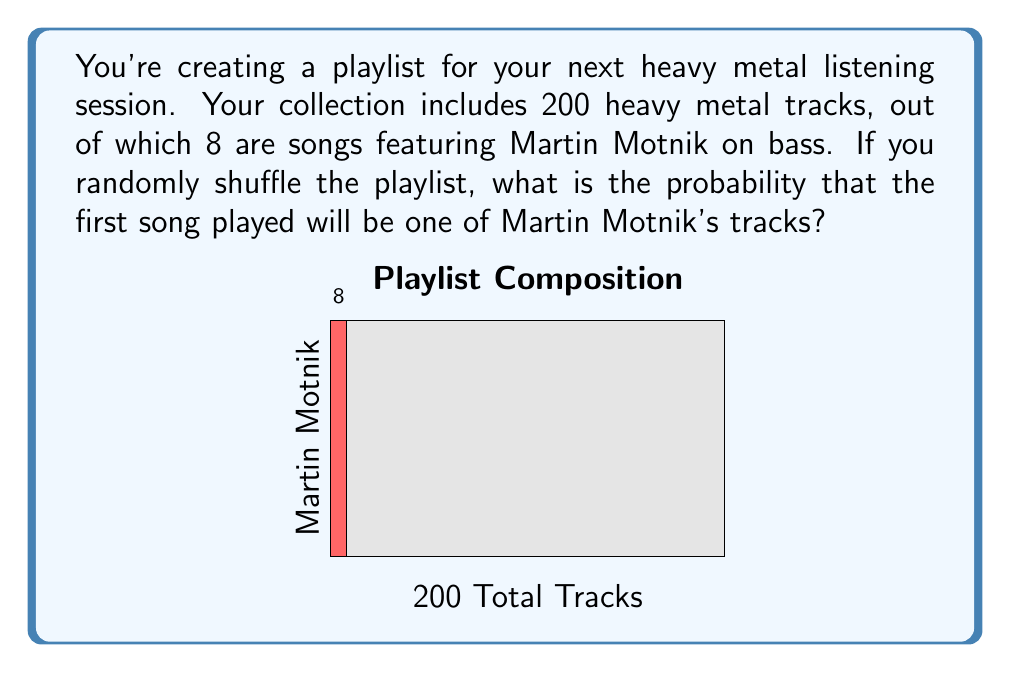Solve this math problem. Let's approach this step-by-step:

1) First, we need to identify the probability space:
   - Total number of tracks: 200
   - Number of tracks featuring Martin Motnik: 8

2) The probability of an event is calculated by:

   $$P(\text{event}) = \frac{\text{number of favorable outcomes}}{\text{total number of possible outcomes}}$$

3) In this case:
   - Favorable outcomes: 8 (Martin Motnik tracks)
   - Total possible outcomes: 200 (all tracks)

4) Applying the formula:

   $$P(\text{Martin Motnik track}) = \frac{8}{200}$$

5) Simplify the fraction:

   $$P(\text{Martin Motnik track}) = \frac{1}{25} = 0.04$$

6) Convert to percentage:

   $$0.04 \times 100\% = 4\%$$

Therefore, there is a 4% chance that the first song played will be a Martin Motnik track.
Answer: $\frac{1}{25}$ or 0.04 or 4% 